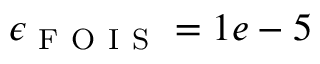Convert formula to latex. <formula><loc_0><loc_0><loc_500><loc_500>\epsilon _ { F O I S } = 1 e - 5</formula> 